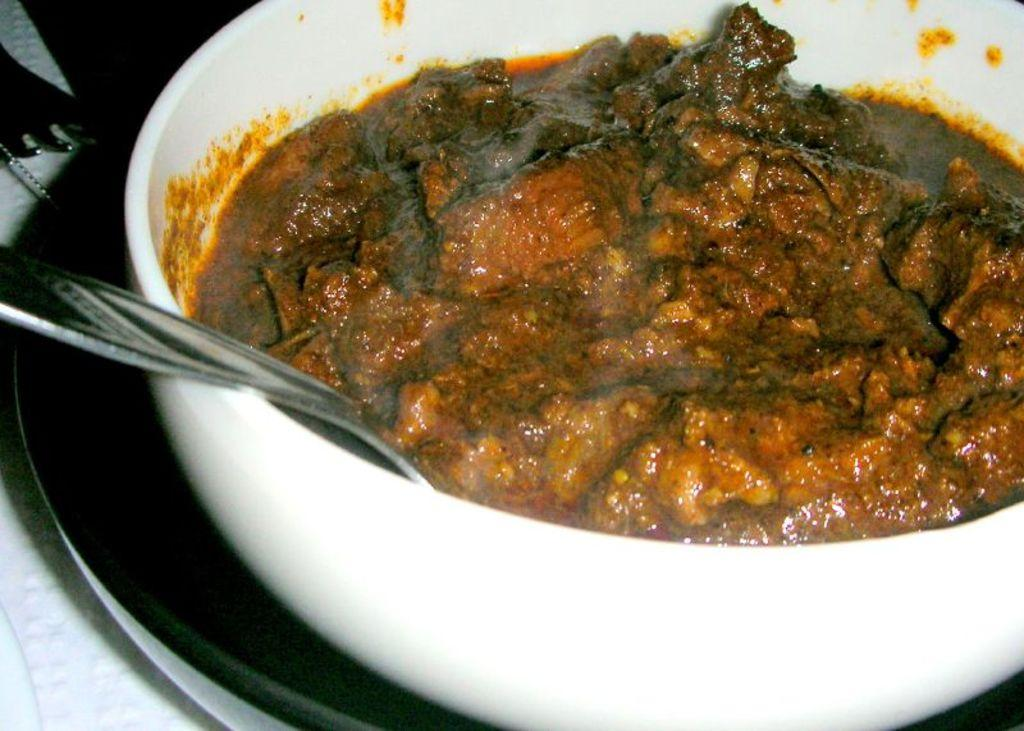What piece of furniture is present in the image? There is a table in the image. What utensil can be seen on the table? There is a fork on the table. What is covering the table in the image? There is a cloth on the table. What dishware is present on the table? There is a plate on the table. What type of food item is in the bowl on the table? There is a bowl containing a food item on the table. What utensil is used for stirring or scooping in the image? There is a spoon on the table. How many rivers can be seen flowing through the food item in the bowl? There are no rivers present in the image, as it features a table with various items on it. 